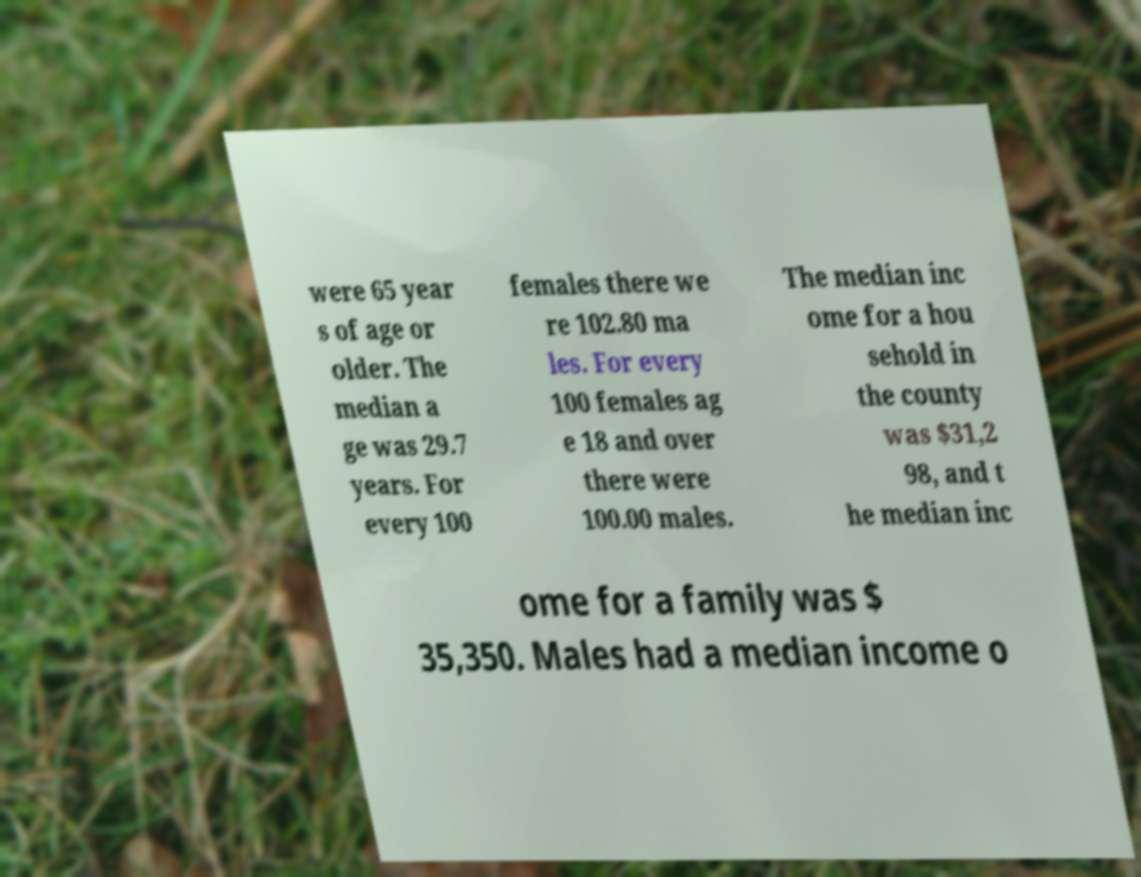Could you extract and type out the text from this image? were 65 year s of age or older. The median a ge was 29.7 years. For every 100 females there we re 102.80 ma les. For every 100 females ag e 18 and over there were 100.00 males. The median inc ome for a hou sehold in the county was $31,2 98, and t he median inc ome for a family was $ 35,350. Males had a median income o 